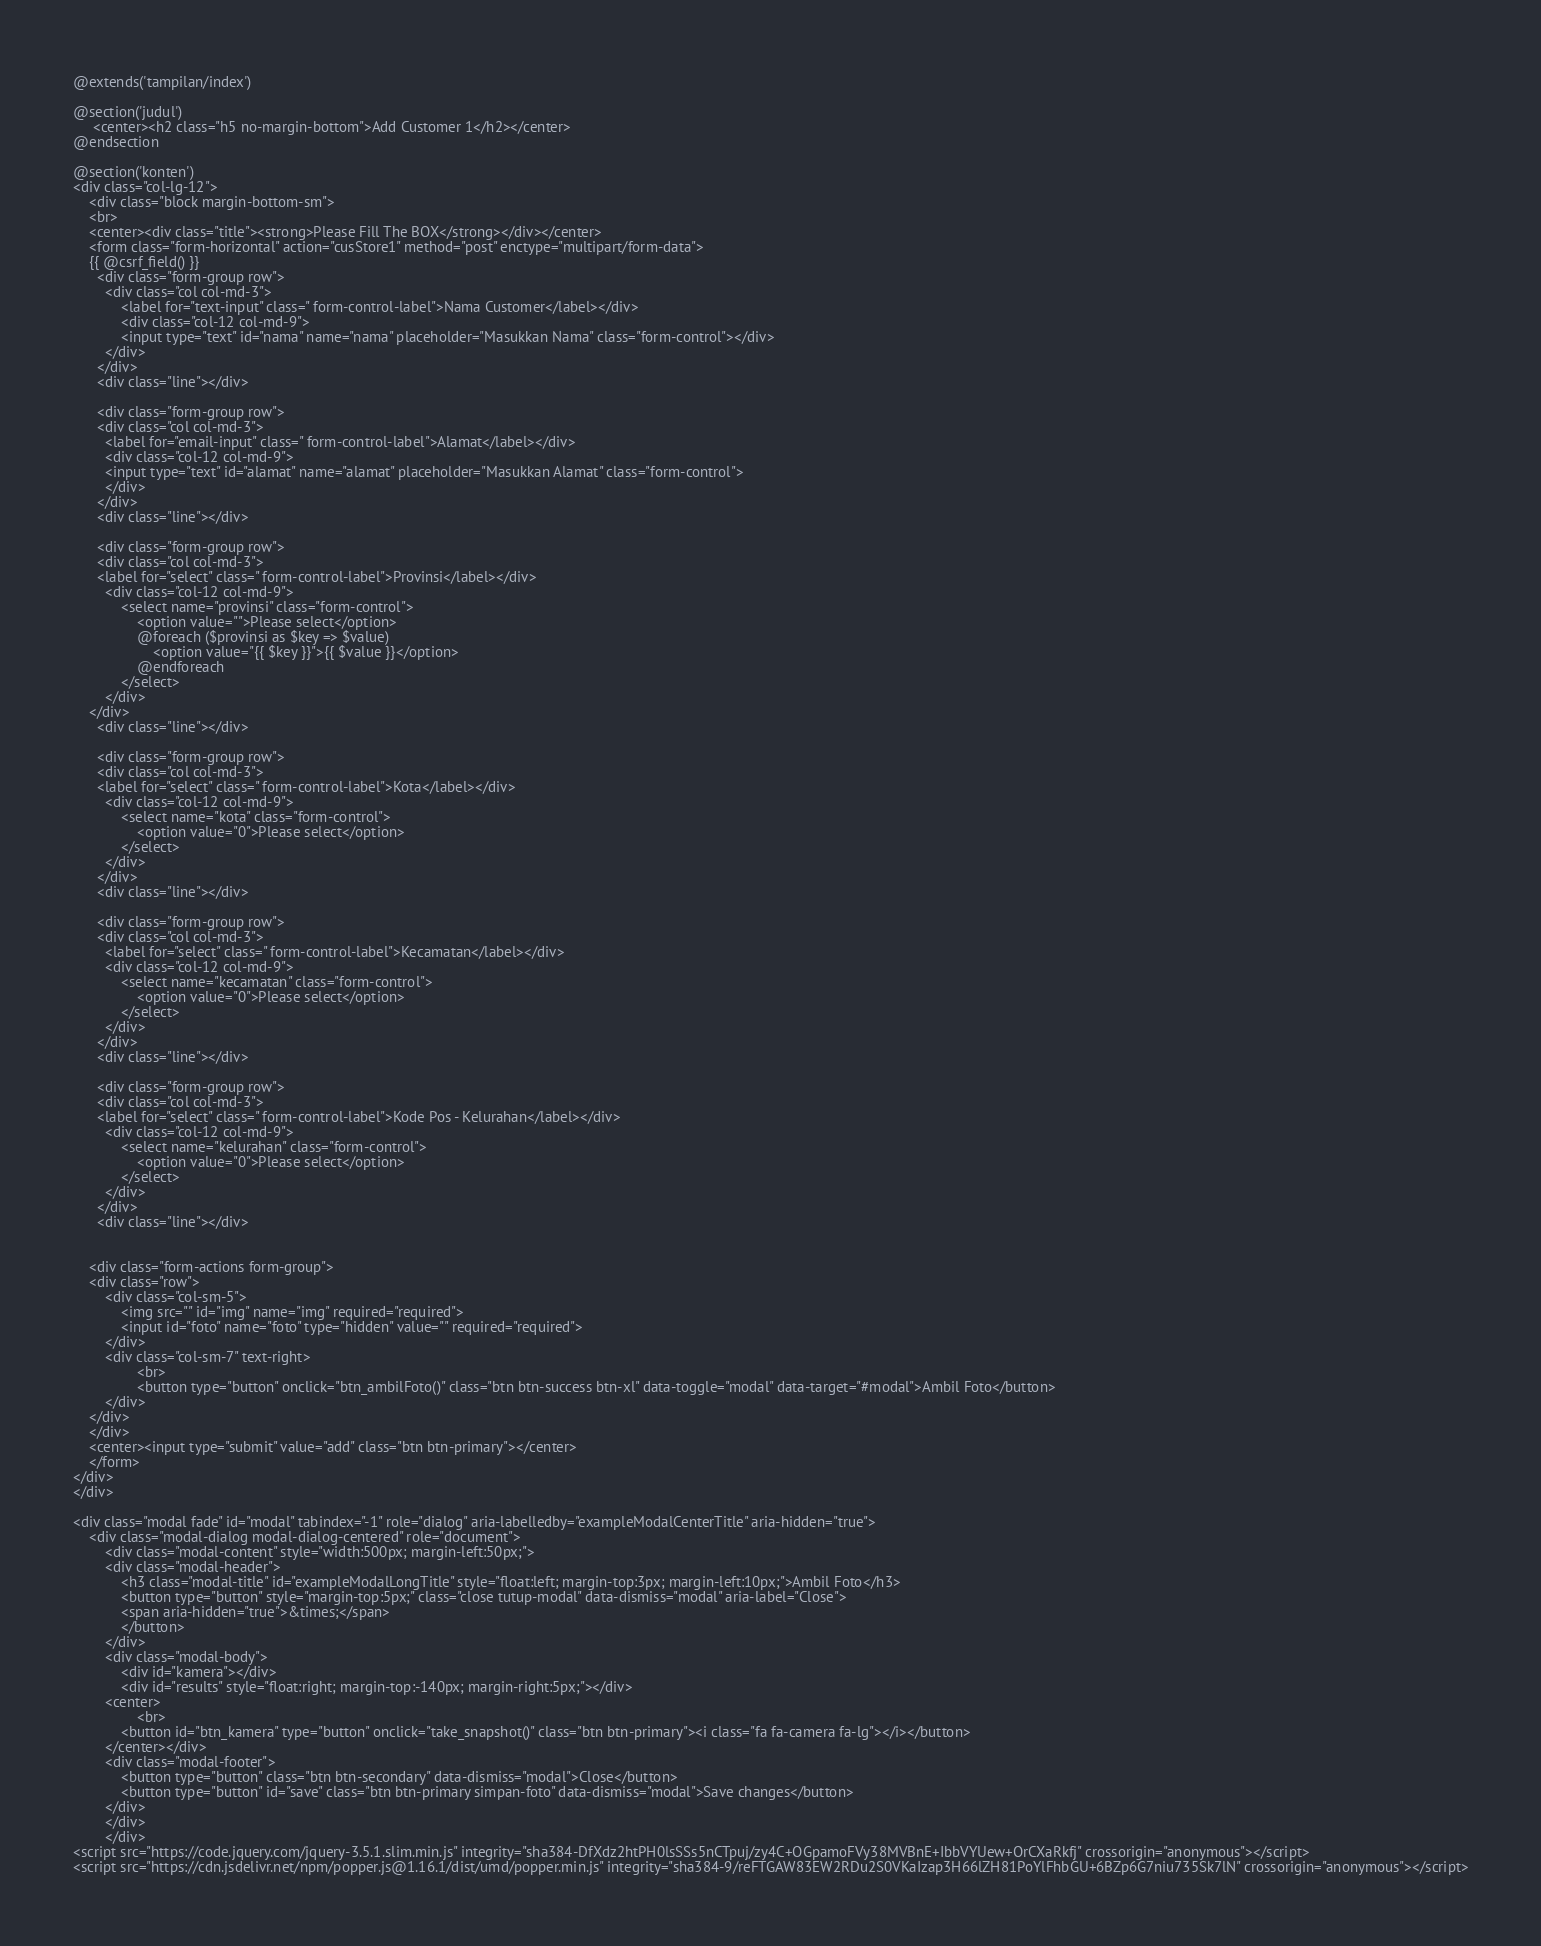<code> <loc_0><loc_0><loc_500><loc_500><_PHP_>@extends('tampilan/index')

@section('judul')
     <center><h2 class="h5 no-margin-bottom">Add Customer 1</h2></center>
@endsection

@section('konten')
<div class="col-lg-12">
	<div class="block margin-bottom-sm">
    <br>
    <center><div class="title"><strong>Please Fill The BOX</strong></div></center>
	<form class="form-horizontal" action="cusStore1" method="post" enctype="multipart/form-data">
	{{ @csrf_field() }}
	  <div class="form-group row">
		<div class="col col-md-3">
			<label for="text-input" class=" form-control-label">Nama Customer</label></div>
			<div class="col-12 col-md-9">
			<input type="text" id="nama" name="nama" placeholder="Masukkan Nama" class="form-control"></div>
		</div>
	  </div>
	  <div class="line"></div>
 
	  <div class="form-group row">
	  <div class="col col-md-3">
	  	<label for="email-input" class=" form-control-label">Alamat</label></div>
		<div class="col-12 col-md-9">
		<input type="text" id="alamat" name="alamat" placeholder="Masukkan Alamat" class="form-control">
		</div>
	  </div>
	  <div class="line"></div>

	  <div class="form-group row">
	  <div class="col col-md-3">
	  <label for="select" class=" form-control-label">Provinsi</label></div>
		<div class="col-12 col-md-9">
			<select name="provinsi" class="form-control">
				<option value="">Please select</option>
				@foreach ($provinsi as $key => $value)
					<option value="{{ $key }}">{{ $value }}</option>
				@endforeach
			</select>
		</div>
	</div>
	  <div class="line"></div>

	  <div class="form-group row">
	  <div class="col col-md-3">
	  <label for="select" class=" form-control-label">Kota</label></div>
		<div class="col-12 col-md-9">
			<select name="kota" class="form-control">
				<option value="0">Please select</option>
			</select>
		</div>
	  </div>
	  <div class="line"></div>

	  <div class="form-group row">
	  <div class="col col-md-3">
	  	<label for="select" class=" form-control-label">Kecamatan</label></div>
		<div class="col-12 col-md-9">
			<select name="kecamatan" class="form-control">
				<option value="0">Please select</option>
			</select>
		</div>
	  </div>
	  <div class="line"></div>

	  <div class="form-group row">
	  <div class="col col-md-3">
	  <label for="select" class=" form-control-label">Kode Pos - Kelurahan</label></div>
		<div class="col-12 col-md-9">
			<select name="kelurahan" class="form-control">
				<option value="0">Please select</option>
			</select>
		</div>
	  </div>
	  <div class="line"></div>


	<div class="form-actions form-group">
	<div class="row">
		<div class="col-sm-5">
            <img src="" id="img" name="img" required="required">
            <input id="foto" name="foto" type="hidden" value="" required="required">
		</div>
		<div class="col-sm-7" text-right>
				<br>
				<button type="button" onclick="btn_ambilFoto()" class="btn btn-success btn-xl" data-toggle="modal" data-target="#modal">Ambil Foto</button>
		</div>
	</div>
	</div>
	<center><input type="submit" value="add" class="btn btn-primary"></center>
	</form>
</div>
</div>

<div class="modal fade" id="modal" tabindex="-1" role="dialog" aria-labelledby="exampleModalCenterTitle" aria-hidden="true">
	<div class="modal-dialog modal-dialog-centered" role="document">
		<div class="modal-content" style="width:500px; margin-left:50px;">
		<div class="modal-header">
			<h3 class="modal-title" id="exampleModalLongTitle" style="float:left; margin-top:3px; margin-left:10px;">Ambil Foto</h3>
			<button type="button" style="margin-top:5px;" class="close tutup-modal" data-dismiss="modal" aria-label="Close">
			<span aria-hidden="true">&times;</span>
			</button>
		</div>
		<div class="modal-body">
			<div id="kamera"></div>
			<div id="results" style="float:right; margin-top:-140px; margin-right:5px;"></div>
		<center>
				<br>
			<button id="btn_kamera" type="button" onclick="take_snapshot()" class="btn btn-primary"><i class="fa fa-camera fa-lg"></i></button>
		</center></div>
		<div class="modal-footer">
			<button type="button" class="btn btn-secondary" data-dismiss="modal">Close</button>
			<button type="button" id="save" class="btn btn-primary simpan-foto" data-dismiss="modal">Save changes</button>
		</div>
		</div>
		</div>
<script src="https://code.jquery.com/jquery-3.5.1.slim.min.js" integrity="sha384-DfXdz2htPH0lsSSs5nCTpuj/zy4C+OGpamoFVy38MVBnE+IbbVYUew+OrCXaRkfj" crossorigin="anonymous"></script>
<script src="https://cdn.jsdelivr.net/npm/popper.js@1.16.1/dist/umd/popper.min.js" integrity="sha384-9/reFTGAW83EW2RDu2S0VKaIzap3H66lZH81PoYlFhbGU+6BZp6G7niu735Sk7lN" crossorigin="anonymous"></script></code> 